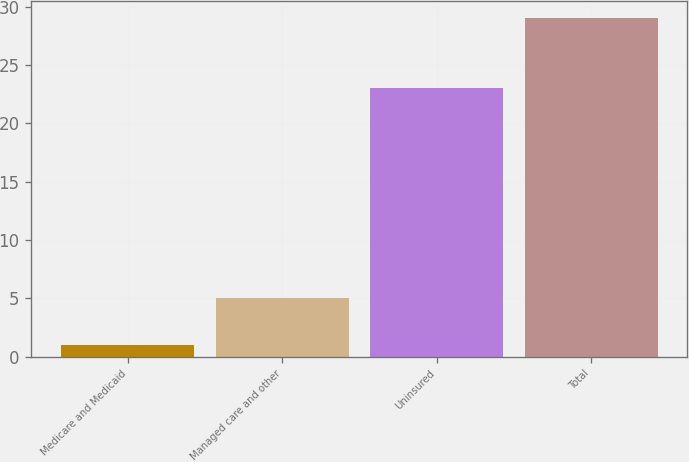Convert chart to OTSL. <chart><loc_0><loc_0><loc_500><loc_500><bar_chart><fcel>Medicare and Medicaid<fcel>Managed care and other<fcel>Uninsured<fcel>Total<nl><fcel>1<fcel>5<fcel>23<fcel>29<nl></chart> 